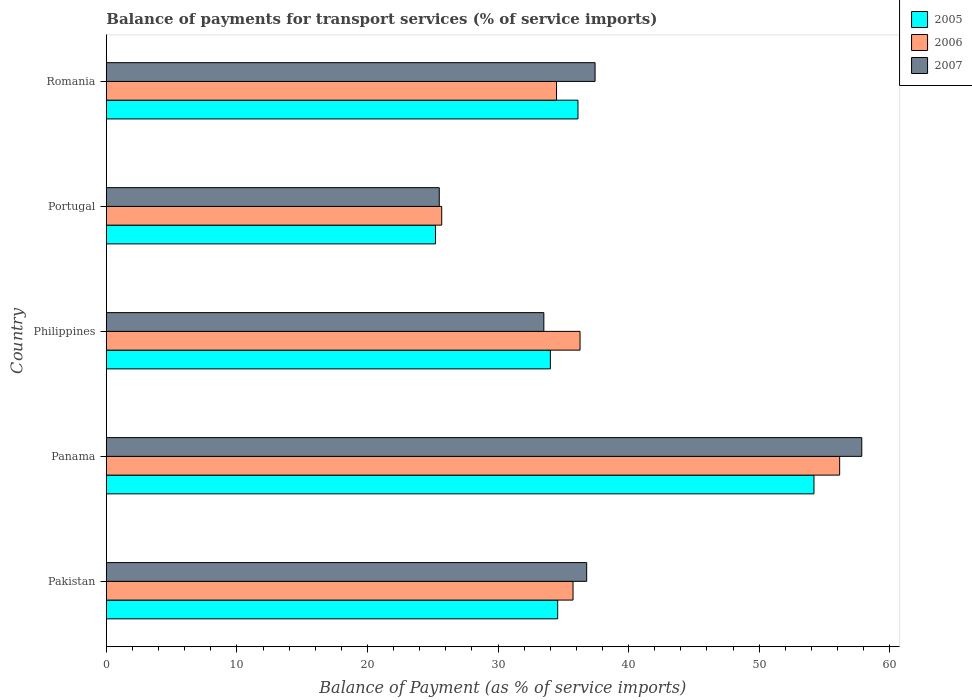How many groups of bars are there?
Provide a short and direct response. 5. In how many cases, is the number of bars for a given country not equal to the number of legend labels?
Your answer should be compact. 0. What is the balance of payments for transport services in 2006 in Portugal?
Your answer should be compact. 25.69. Across all countries, what is the maximum balance of payments for transport services in 2007?
Offer a terse response. 57.86. Across all countries, what is the minimum balance of payments for transport services in 2006?
Provide a succinct answer. 25.69. In which country was the balance of payments for transport services in 2007 maximum?
Give a very brief answer. Panama. What is the total balance of payments for transport services in 2007 in the graph?
Your response must be concise. 191.11. What is the difference between the balance of payments for transport services in 2006 in Pakistan and that in Portugal?
Provide a succinct answer. 10.06. What is the difference between the balance of payments for transport services in 2006 in Panama and the balance of payments for transport services in 2007 in Philippines?
Your answer should be compact. 22.66. What is the average balance of payments for transport services in 2006 per country?
Your answer should be compact. 37.67. What is the difference between the balance of payments for transport services in 2007 and balance of payments for transport services in 2006 in Romania?
Provide a succinct answer. 2.95. What is the ratio of the balance of payments for transport services in 2007 in Panama to that in Philippines?
Offer a very short reply. 1.73. What is the difference between the highest and the second highest balance of payments for transport services in 2005?
Give a very brief answer. 18.07. What is the difference between the highest and the lowest balance of payments for transport services in 2006?
Offer a very short reply. 30.48. In how many countries, is the balance of payments for transport services in 2007 greater than the average balance of payments for transport services in 2007 taken over all countries?
Your answer should be compact. 1. What does the 1st bar from the top in Panama represents?
Offer a terse response. 2007. Is it the case that in every country, the sum of the balance of payments for transport services in 2007 and balance of payments for transport services in 2006 is greater than the balance of payments for transport services in 2005?
Provide a succinct answer. Yes. Are all the bars in the graph horizontal?
Ensure brevity in your answer.  Yes. How many countries are there in the graph?
Your answer should be compact. 5. How are the legend labels stacked?
Your answer should be compact. Vertical. What is the title of the graph?
Provide a succinct answer. Balance of payments for transport services (% of service imports). What is the label or title of the X-axis?
Offer a terse response. Balance of Payment (as % of service imports). What is the Balance of Payment (as % of service imports) in 2005 in Pakistan?
Keep it short and to the point. 34.57. What is the Balance of Payment (as % of service imports) in 2006 in Pakistan?
Provide a short and direct response. 35.75. What is the Balance of Payment (as % of service imports) of 2007 in Pakistan?
Your answer should be very brief. 36.79. What is the Balance of Payment (as % of service imports) in 2005 in Panama?
Your answer should be compact. 54.2. What is the Balance of Payment (as % of service imports) of 2006 in Panama?
Provide a succinct answer. 56.17. What is the Balance of Payment (as % of service imports) in 2007 in Panama?
Offer a very short reply. 57.86. What is the Balance of Payment (as % of service imports) of 2005 in Philippines?
Provide a succinct answer. 34.01. What is the Balance of Payment (as % of service imports) in 2006 in Philippines?
Provide a succinct answer. 36.28. What is the Balance of Payment (as % of service imports) in 2007 in Philippines?
Ensure brevity in your answer.  33.51. What is the Balance of Payment (as % of service imports) in 2005 in Portugal?
Ensure brevity in your answer.  25.21. What is the Balance of Payment (as % of service imports) of 2006 in Portugal?
Ensure brevity in your answer.  25.69. What is the Balance of Payment (as % of service imports) in 2007 in Portugal?
Keep it short and to the point. 25.5. What is the Balance of Payment (as % of service imports) of 2005 in Romania?
Your response must be concise. 36.13. What is the Balance of Payment (as % of service imports) of 2006 in Romania?
Give a very brief answer. 34.48. What is the Balance of Payment (as % of service imports) of 2007 in Romania?
Keep it short and to the point. 37.44. Across all countries, what is the maximum Balance of Payment (as % of service imports) in 2005?
Keep it short and to the point. 54.2. Across all countries, what is the maximum Balance of Payment (as % of service imports) of 2006?
Make the answer very short. 56.17. Across all countries, what is the maximum Balance of Payment (as % of service imports) of 2007?
Offer a very short reply. 57.86. Across all countries, what is the minimum Balance of Payment (as % of service imports) of 2005?
Keep it short and to the point. 25.21. Across all countries, what is the minimum Balance of Payment (as % of service imports) in 2006?
Ensure brevity in your answer.  25.69. Across all countries, what is the minimum Balance of Payment (as % of service imports) in 2007?
Offer a very short reply. 25.5. What is the total Balance of Payment (as % of service imports) of 2005 in the graph?
Offer a terse response. 184.12. What is the total Balance of Payment (as % of service imports) in 2006 in the graph?
Provide a succinct answer. 188.37. What is the total Balance of Payment (as % of service imports) in 2007 in the graph?
Offer a terse response. 191.11. What is the difference between the Balance of Payment (as % of service imports) of 2005 in Pakistan and that in Panama?
Offer a terse response. -19.63. What is the difference between the Balance of Payment (as % of service imports) in 2006 in Pakistan and that in Panama?
Ensure brevity in your answer.  -20.42. What is the difference between the Balance of Payment (as % of service imports) in 2007 in Pakistan and that in Panama?
Give a very brief answer. -21.07. What is the difference between the Balance of Payment (as % of service imports) of 2005 in Pakistan and that in Philippines?
Offer a very short reply. 0.56. What is the difference between the Balance of Payment (as % of service imports) of 2006 in Pakistan and that in Philippines?
Offer a terse response. -0.54. What is the difference between the Balance of Payment (as % of service imports) in 2007 in Pakistan and that in Philippines?
Provide a short and direct response. 3.28. What is the difference between the Balance of Payment (as % of service imports) in 2005 in Pakistan and that in Portugal?
Make the answer very short. 9.36. What is the difference between the Balance of Payment (as % of service imports) in 2006 in Pakistan and that in Portugal?
Offer a very short reply. 10.06. What is the difference between the Balance of Payment (as % of service imports) in 2007 in Pakistan and that in Portugal?
Provide a succinct answer. 11.29. What is the difference between the Balance of Payment (as % of service imports) of 2005 in Pakistan and that in Romania?
Your answer should be compact. -1.56. What is the difference between the Balance of Payment (as % of service imports) in 2006 in Pakistan and that in Romania?
Ensure brevity in your answer.  1.26. What is the difference between the Balance of Payment (as % of service imports) of 2007 in Pakistan and that in Romania?
Ensure brevity in your answer.  -0.64. What is the difference between the Balance of Payment (as % of service imports) in 2005 in Panama and that in Philippines?
Make the answer very short. 20.19. What is the difference between the Balance of Payment (as % of service imports) of 2006 in Panama and that in Philippines?
Keep it short and to the point. 19.88. What is the difference between the Balance of Payment (as % of service imports) in 2007 in Panama and that in Philippines?
Provide a succinct answer. 24.35. What is the difference between the Balance of Payment (as % of service imports) of 2005 in Panama and that in Portugal?
Keep it short and to the point. 28.99. What is the difference between the Balance of Payment (as % of service imports) of 2006 in Panama and that in Portugal?
Your answer should be compact. 30.48. What is the difference between the Balance of Payment (as % of service imports) of 2007 in Panama and that in Portugal?
Provide a short and direct response. 32.36. What is the difference between the Balance of Payment (as % of service imports) in 2005 in Panama and that in Romania?
Provide a succinct answer. 18.07. What is the difference between the Balance of Payment (as % of service imports) of 2006 in Panama and that in Romania?
Give a very brief answer. 21.69. What is the difference between the Balance of Payment (as % of service imports) in 2007 in Panama and that in Romania?
Keep it short and to the point. 20.43. What is the difference between the Balance of Payment (as % of service imports) of 2006 in Philippines and that in Portugal?
Offer a very short reply. 10.6. What is the difference between the Balance of Payment (as % of service imports) of 2007 in Philippines and that in Portugal?
Offer a very short reply. 8.01. What is the difference between the Balance of Payment (as % of service imports) of 2005 in Philippines and that in Romania?
Keep it short and to the point. -2.12. What is the difference between the Balance of Payment (as % of service imports) in 2006 in Philippines and that in Romania?
Keep it short and to the point. 1.8. What is the difference between the Balance of Payment (as % of service imports) in 2007 in Philippines and that in Romania?
Your answer should be very brief. -3.92. What is the difference between the Balance of Payment (as % of service imports) in 2005 in Portugal and that in Romania?
Offer a terse response. -10.92. What is the difference between the Balance of Payment (as % of service imports) of 2006 in Portugal and that in Romania?
Offer a terse response. -8.79. What is the difference between the Balance of Payment (as % of service imports) of 2007 in Portugal and that in Romania?
Your response must be concise. -11.93. What is the difference between the Balance of Payment (as % of service imports) of 2005 in Pakistan and the Balance of Payment (as % of service imports) of 2006 in Panama?
Your answer should be compact. -21.6. What is the difference between the Balance of Payment (as % of service imports) in 2005 in Pakistan and the Balance of Payment (as % of service imports) in 2007 in Panama?
Make the answer very short. -23.29. What is the difference between the Balance of Payment (as % of service imports) in 2006 in Pakistan and the Balance of Payment (as % of service imports) in 2007 in Panama?
Your answer should be very brief. -22.12. What is the difference between the Balance of Payment (as % of service imports) of 2005 in Pakistan and the Balance of Payment (as % of service imports) of 2006 in Philippines?
Provide a succinct answer. -1.71. What is the difference between the Balance of Payment (as % of service imports) of 2005 in Pakistan and the Balance of Payment (as % of service imports) of 2007 in Philippines?
Ensure brevity in your answer.  1.06. What is the difference between the Balance of Payment (as % of service imports) of 2006 in Pakistan and the Balance of Payment (as % of service imports) of 2007 in Philippines?
Your response must be concise. 2.23. What is the difference between the Balance of Payment (as % of service imports) in 2005 in Pakistan and the Balance of Payment (as % of service imports) in 2006 in Portugal?
Your answer should be compact. 8.88. What is the difference between the Balance of Payment (as % of service imports) of 2005 in Pakistan and the Balance of Payment (as % of service imports) of 2007 in Portugal?
Your response must be concise. 9.07. What is the difference between the Balance of Payment (as % of service imports) of 2006 in Pakistan and the Balance of Payment (as % of service imports) of 2007 in Portugal?
Give a very brief answer. 10.25. What is the difference between the Balance of Payment (as % of service imports) of 2005 in Pakistan and the Balance of Payment (as % of service imports) of 2006 in Romania?
Your response must be concise. 0.09. What is the difference between the Balance of Payment (as % of service imports) of 2005 in Pakistan and the Balance of Payment (as % of service imports) of 2007 in Romania?
Provide a short and direct response. -2.86. What is the difference between the Balance of Payment (as % of service imports) of 2006 in Pakistan and the Balance of Payment (as % of service imports) of 2007 in Romania?
Ensure brevity in your answer.  -1.69. What is the difference between the Balance of Payment (as % of service imports) in 2005 in Panama and the Balance of Payment (as % of service imports) in 2006 in Philippines?
Make the answer very short. 17.92. What is the difference between the Balance of Payment (as % of service imports) of 2005 in Panama and the Balance of Payment (as % of service imports) of 2007 in Philippines?
Provide a succinct answer. 20.69. What is the difference between the Balance of Payment (as % of service imports) in 2006 in Panama and the Balance of Payment (as % of service imports) in 2007 in Philippines?
Provide a short and direct response. 22.66. What is the difference between the Balance of Payment (as % of service imports) in 2005 in Panama and the Balance of Payment (as % of service imports) in 2006 in Portugal?
Keep it short and to the point. 28.51. What is the difference between the Balance of Payment (as % of service imports) in 2005 in Panama and the Balance of Payment (as % of service imports) in 2007 in Portugal?
Your answer should be compact. 28.7. What is the difference between the Balance of Payment (as % of service imports) of 2006 in Panama and the Balance of Payment (as % of service imports) of 2007 in Portugal?
Keep it short and to the point. 30.67. What is the difference between the Balance of Payment (as % of service imports) of 2005 in Panama and the Balance of Payment (as % of service imports) of 2006 in Romania?
Your answer should be very brief. 19.72. What is the difference between the Balance of Payment (as % of service imports) of 2005 in Panama and the Balance of Payment (as % of service imports) of 2007 in Romania?
Ensure brevity in your answer.  16.77. What is the difference between the Balance of Payment (as % of service imports) of 2006 in Panama and the Balance of Payment (as % of service imports) of 2007 in Romania?
Your answer should be compact. 18.73. What is the difference between the Balance of Payment (as % of service imports) in 2005 in Philippines and the Balance of Payment (as % of service imports) in 2006 in Portugal?
Give a very brief answer. 8.32. What is the difference between the Balance of Payment (as % of service imports) of 2005 in Philippines and the Balance of Payment (as % of service imports) of 2007 in Portugal?
Your response must be concise. 8.51. What is the difference between the Balance of Payment (as % of service imports) in 2006 in Philippines and the Balance of Payment (as % of service imports) in 2007 in Portugal?
Offer a very short reply. 10.78. What is the difference between the Balance of Payment (as % of service imports) in 2005 in Philippines and the Balance of Payment (as % of service imports) in 2006 in Romania?
Your response must be concise. -0.47. What is the difference between the Balance of Payment (as % of service imports) of 2005 in Philippines and the Balance of Payment (as % of service imports) of 2007 in Romania?
Give a very brief answer. -3.42. What is the difference between the Balance of Payment (as % of service imports) in 2006 in Philippines and the Balance of Payment (as % of service imports) in 2007 in Romania?
Keep it short and to the point. -1.15. What is the difference between the Balance of Payment (as % of service imports) in 2005 in Portugal and the Balance of Payment (as % of service imports) in 2006 in Romania?
Provide a short and direct response. -9.27. What is the difference between the Balance of Payment (as % of service imports) of 2005 in Portugal and the Balance of Payment (as % of service imports) of 2007 in Romania?
Your answer should be very brief. -12.22. What is the difference between the Balance of Payment (as % of service imports) of 2006 in Portugal and the Balance of Payment (as % of service imports) of 2007 in Romania?
Your answer should be compact. -11.75. What is the average Balance of Payment (as % of service imports) in 2005 per country?
Offer a terse response. 36.82. What is the average Balance of Payment (as % of service imports) of 2006 per country?
Provide a succinct answer. 37.67. What is the average Balance of Payment (as % of service imports) in 2007 per country?
Ensure brevity in your answer.  38.22. What is the difference between the Balance of Payment (as % of service imports) of 2005 and Balance of Payment (as % of service imports) of 2006 in Pakistan?
Your answer should be very brief. -1.17. What is the difference between the Balance of Payment (as % of service imports) in 2005 and Balance of Payment (as % of service imports) in 2007 in Pakistan?
Offer a terse response. -2.22. What is the difference between the Balance of Payment (as % of service imports) in 2006 and Balance of Payment (as % of service imports) in 2007 in Pakistan?
Ensure brevity in your answer.  -1.04. What is the difference between the Balance of Payment (as % of service imports) of 2005 and Balance of Payment (as % of service imports) of 2006 in Panama?
Provide a succinct answer. -1.97. What is the difference between the Balance of Payment (as % of service imports) of 2005 and Balance of Payment (as % of service imports) of 2007 in Panama?
Make the answer very short. -3.66. What is the difference between the Balance of Payment (as % of service imports) in 2006 and Balance of Payment (as % of service imports) in 2007 in Panama?
Provide a short and direct response. -1.7. What is the difference between the Balance of Payment (as % of service imports) of 2005 and Balance of Payment (as % of service imports) of 2006 in Philippines?
Offer a very short reply. -2.27. What is the difference between the Balance of Payment (as % of service imports) of 2005 and Balance of Payment (as % of service imports) of 2007 in Philippines?
Provide a short and direct response. 0.5. What is the difference between the Balance of Payment (as % of service imports) of 2006 and Balance of Payment (as % of service imports) of 2007 in Philippines?
Provide a succinct answer. 2.77. What is the difference between the Balance of Payment (as % of service imports) in 2005 and Balance of Payment (as % of service imports) in 2006 in Portugal?
Your response must be concise. -0.48. What is the difference between the Balance of Payment (as % of service imports) in 2005 and Balance of Payment (as % of service imports) in 2007 in Portugal?
Make the answer very short. -0.29. What is the difference between the Balance of Payment (as % of service imports) in 2006 and Balance of Payment (as % of service imports) in 2007 in Portugal?
Make the answer very short. 0.19. What is the difference between the Balance of Payment (as % of service imports) in 2005 and Balance of Payment (as % of service imports) in 2006 in Romania?
Give a very brief answer. 1.64. What is the difference between the Balance of Payment (as % of service imports) of 2005 and Balance of Payment (as % of service imports) of 2007 in Romania?
Provide a succinct answer. -1.31. What is the difference between the Balance of Payment (as % of service imports) in 2006 and Balance of Payment (as % of service imports) in 2007 in Romania?
Give a very brief answer. -2.95. What is the ratio of the Balance of Payment (as % of service imports) in 2005 in Pakistan to that in Panama?
Provide a short and direct response. 0.64. What is the ratio of the Balance of Payment (as % of service imports) in 2006 in Pakistan to that in Panama?
Give a very brief answer. 0.64. What is the ratio of the Balance of Payment (as % of service imports) of 2007 in Pakistan to that in Panama?
Your answer should be very brief. 0.64. What is the ratio of the Balance of Payment (as % of service imports) of 2005 in Pakistan to that in Philippines?
Provide a succinct answer. 1.02. What is the ratio of the Balance of Payment (as % of service imports) in 2006 in Pakistan to that in Philippines?
Your response must be concise. 0.99. What is the ratio of the Balance of Payment (as % of service imports) in 2007 in Pakistan to that in Philippines?
Offer a very short reply. 1.1. What is the ratio of the Balance of Payment (as % of service imports) of 2005 in Pakistan to that in Portugal?
Offer a terse response. 1.37. What is the ratio of the Balance of Payment (as % of service imports) in 2006 in Pakistan to that in Portugal?
Your answer should be compact. 1.39. What is the ratio of the Balance of Payment (as % of service imports) in 2007 in Pakistan to that in Portugal?
Keep it short and to the point. 1.44. What is the ratio of the Balance of Payment (as % of service imports) of 2005 in Pakistan to that in Romania?
Your answer should be compact. 0.96. What is the ratio of the Balance of Payment (as % of service imports) in 2006 in Pakistan to that in Romania?
Your answer should be compact. 1.04. What is the ratio of the Balance of Payment (as % of service imports) of 2007 in Pakistan to that in Romania?
Provide a short and direct response. 0.98. What is the ratio of the Balance of Payment (as % of service imports) in 2005 in Panama to that in Philippines?
Provide a succinct answer. 1.59. What is the ratio of the Balance of Payment (as % of service imports) in 2006 in Panama to that in Philippines?
Ensure brevity in your answer.  1.55. What is the ratio of the Balance of Payment (as % of service imports) of 2007 in Panama to that in Philippines?
Provide a succinct answer. 1.73. What is the ratio of the Balance of Payment (as % of service imports) in 2005 in Panama to that in Portugal?
Offer a very short reply. 2.15. What is the ratio of the Balance of Payment (as % of service imports) of 2006 in Panama to that in Portugal?
Make the answer very short. 2.19. What is the ratio of the Balance of Payment (as % of service imports) in 2007 in Panama to that in Portugal?
Give a very brief answer. 2.27. What is the ratio of the Balance of Payment (as % of service imports) of 2005 in Panama to that in Romania?
Offer a very short reply. 1.5. What is the ratio of the Balance of Payment (as % of service imports) of 2006 in Panama to that in Romania?
Provide a succinct answer. 1.63. What is the ratio of the Balance of Payment (as % of service imports) in 2007 in Panama to that in Romania?
Your answer should be very brief. 1.55. What is the ratio of the Balance of Payment (as % of service imports) in 2005 in Philippines to that in Portugal?
Provide a short and direct response. 1.35. What is the ratio of the Balance of Payment (as % of service imports) of 2006 in Philippines to that in Portugal?
Give a very brief answer. 1.41. What is the ratio of the Balance of Payment (as % of service imports) in 2007 in Philippines to that in Portugal?
Offer a very short reply. 1.31. What is the ratio of the Balance of Payment (as % of service imports) of 2005 in Philippines to that in Romania?
Provide a short and direct response. 0.94. What is the ratio of the Balance of Payment (as % of service imports) in 2006 in Philippines to that in Romania?
Your response must be concise. 1.05. What is the ratio of the Balance of Payment (as % of service imports) of 2007 in Philippines to that in Romania?
Provide a short and direct response. 0.9. What is the ratio of the Balance of Payment (as % of service imports) in 2005 in Portugal to that in Romania?
Your answer should be compact. 0.7. What is the ratio of the Balance of Payment (as % of service imports) in 2006 in Portugal to that in Romania?
Provide a succinct answer. 0.74. What is the ratio of the Balance of Payment (as % of service imports) in 2007 in Portugal to that in Romania?
Provide a succinct answer. 0.68. What is the difference between the highest and the second highest Balance of Payment (as % of service imports) of 2005?
Offer a very short reply. 18.07. What is the difference between the highest and the second highest Balance of Payment (as % of service imports) of 2006?
Your answer should be compact. 19.88. What is the difference between the highest and the second highest Balance of Payment (as % of service imports) of 2007?
Ensure brevity in your answer.  20.43. What is the difference between the highest and the lowest Balance of Payment (as % of service imports) of 2005?
Provide a succinct answer. 28.99. What is the difference between the highest and the lowest Balance of Payment (as % of service imports) in 2006?
Make the answer very short. 30.48. What is the difference between the highest and the lowest Balance of Payment (as % of service imports) in 2007?
Make the answer very short. 32.36. 